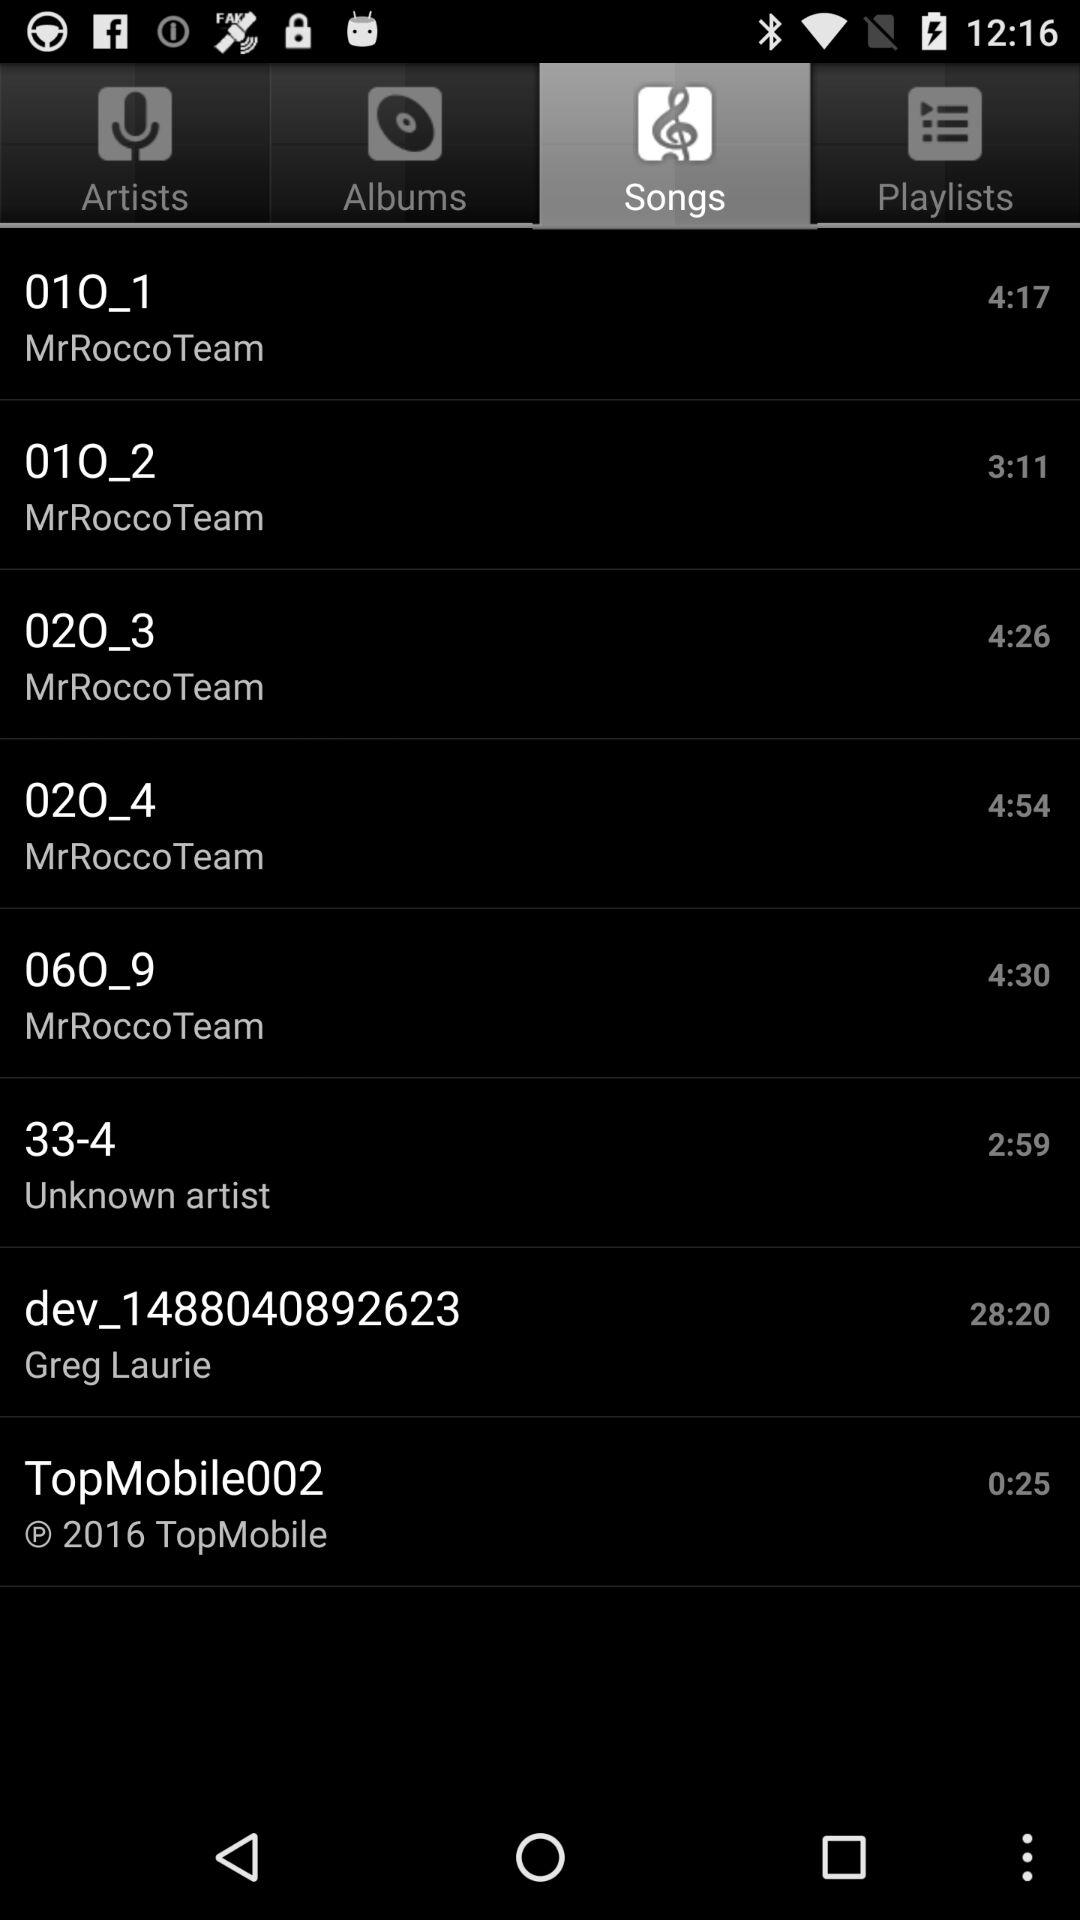Which tab is selected? The selected tab is "Songs". 